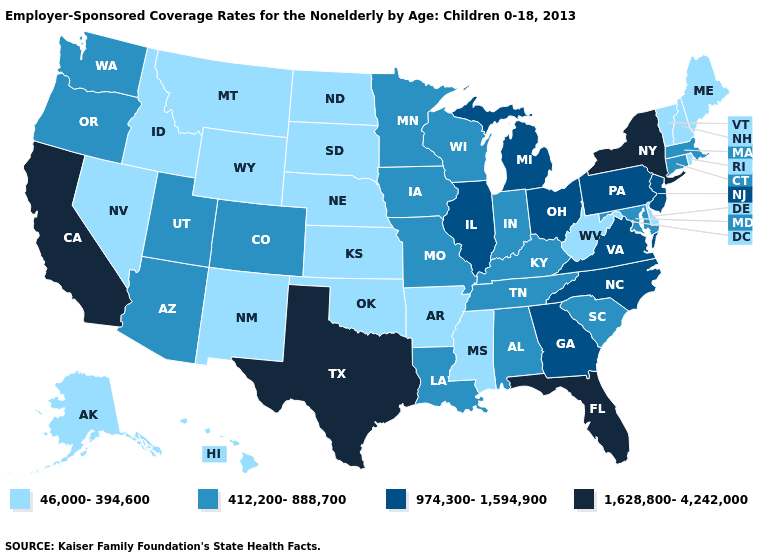What is the lowest value in the MidWest?
Short answer required. 46,000-394,600. What is the highest value in the Northeast ?
Write a very short answer. 1,628,800-4,242,000. What is the value of Indiana?
Short answer required. 412,200-888,700. Name the states that have a value in the range 1,628,800-4,242,000?
Keep it brief. California, Florida, New York, Texas. What is the lowest value in the Northeast?
Keep it brief. 46,000-394,600. Which states hav the highest value in the Northeast?
Write a very short answer. New York. What is the value of New Mexico?
Answer briefly. 46,000-394,600. Which states have the highest value in the USA?
Keep it brief. California, Florida, New York, Texas. Name the states that have a value in the range 974,300-1,594,900?
Short answer required. Georgia, Illinois, Michigan, New Jersey, North Carolina, Ohio, Pennsylvania, Virginia. How many symbols are there in the legend?
Be succinct. 4. Name the states that have a value in the range 412,200-888,700?
Concise answer only. Alabama, Arizona, Colorado, Connecticut, Indiana, Iowa, Kentucky, Louisiana, Maryland, Massachusetts, Minnesota, Missouri, Oregon, South Carolina, Tennessee, Utah, Washington, Wisconsin. Does South Dakota have the same value as Washington?
Short answer required. No. Name the states that have a value in the range 1,628,800-4,242,000?
Be succinct. California, Florida, New York, Texas. Does Minnesota have the highest value in the USA?
Concise answer only. No. Among the states that border South Carolina , which have the lowest value?
Short answer required. Georgia, North Carolina. 